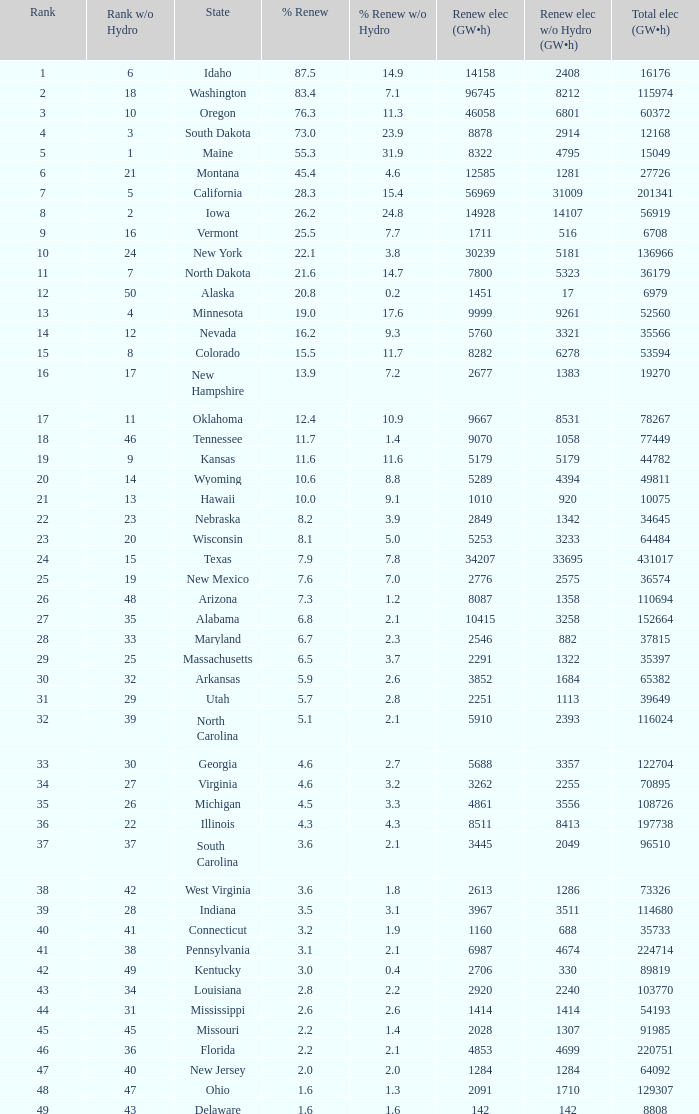Which state has 5179 (gw×h) of renewable energy without hydrogen power?wha Kansas. 